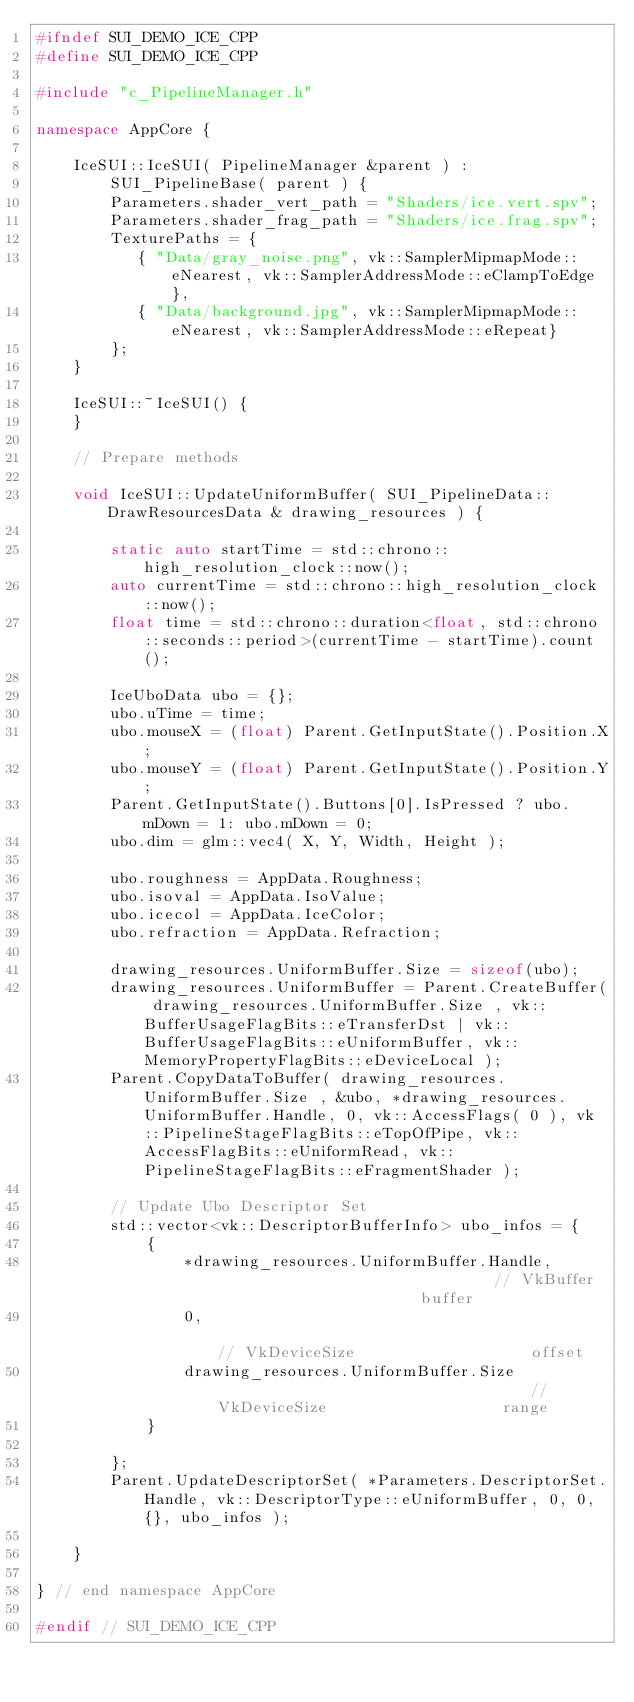Convert code to text. <code><loc_0><loc_0><loc_500><loc_500><_C++_>#ifndef SUI_DEMO_ICE_CPP
#define SUI_DEMO_ICE_CPP

#include "c_PipelineManager.h"

namespace AppCore { 
    
    IceSUI::IceSUI( PipelineManager &parent ) :
        SUI_PipelineBase( parent ) {
        Parameters.shader_vert_path = "Shaders/ice.vert.spv";
        Parameters.shader_frag_path = "Shaders/ice.frag.spv";
        TexturePaths = { 
           { "Data/gray_noise.png", vk::SamplerMipmapMode::eNearest, vk::SamplerAddressMode::eClampToEdge},
           { "Data/background.jpg", vk::SamplerMipmapMode::eNearest, vk::SamplerAddressMode::eRepeat}
        };
    }

    IceSUI::~IceSUI() {
    }

    // Prepare methods

    void IceSUI::UpdateUniformBuffer( SUI_PipelineData::DrawResourcesData & drawing_resources ) {
    
        static auto startTime = std::chrono::high_resolution_clock::now();
        auto currentTime = std::chrono::high_resolution_clock::now();
        float time = std::chrono::duration<float, std::chrono::seconds::period>(currentTime - startTime).count();

        IceUboData ubo = {};
        ubo.uTime = time;
        ubo.mouseX = (float) Parent.GetInputState().Position.X;
        ubo.mouseY = (float) Parent.GetInputState().Position.Y;
        Parent.GetInputState().Buttons[0].IsPressed ? ubo.mDown = 1: ubo.mDown = 0;
        ubo.dim = glm::vec4( X, Y, Width, Height );
        
        ubo.roughness = AppData.Roughness;
        ubo.isoval = AppData.IsoValue;
        ubo.icecol = AppData.IceColor;
        ubo.refraction = AppData.Refraction;

        drawing_resources.UniformBuffer.Size = sizeof(ubo);
        drawing_resources.UniformBuffer = Parent.CreateBuffer( drawing_resources.UniformBuffer.Size , vk::BufferUsageFlagBits::eTransferDst | vk::BufferUsageFlagBits::eUniformBuffer, vk::MemoryPropertyFlagBits::eDeviceLocal );
        Parent.CopyDataToBuffer( drawing_resources.UniformBuffer.Size , &ubo, *drawing_resources.UniformBuffer.Handle, 0, vk::AccessFlags( 0 ), vk::PipelineStageFlagBits::eTopOfPipe, vk::AccessFlagBits::eUniformRead, vk::PipelineStageFlagBits::eFragmentShader );

        // Update Ubo Descriptor Set
        std::vector<vk::DescriptorBufferInfo> ubo_infos = {
            {
                *drawing_resources.UniformBuffer.Handle,                               // VkBuffer                       buffer
                0,                                                                     // VkDeviceSize                   offset
                drawing_resources.UniformBuffer.Size                                   // VkDeviceSize                   range
            }
            
        };
        Parent.UpdateDescriptorSet( *Parameters.DescriptorSet.Handle, vk::DescriptorType::eUniformBuffer, 0, 0, {}, ubo_infos );
    
    }

} // end namespace AppCore

#endif // SUI_DEMO_ICE_CPP</code> 